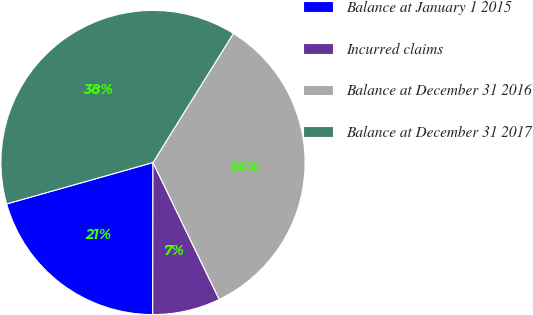<chart> <loc_0><loc_0><loc_500><loc_500><pie_chart><fcel>Balance at January 1 2015<fcel>Incurred claims<fcel>Balance at December 31 2016<fcel>Balance at December 31 2017<nl><fcel>20.58%<fcel>7.2%<fcel>33.96%<fcel>38.26%<nl></chart> 